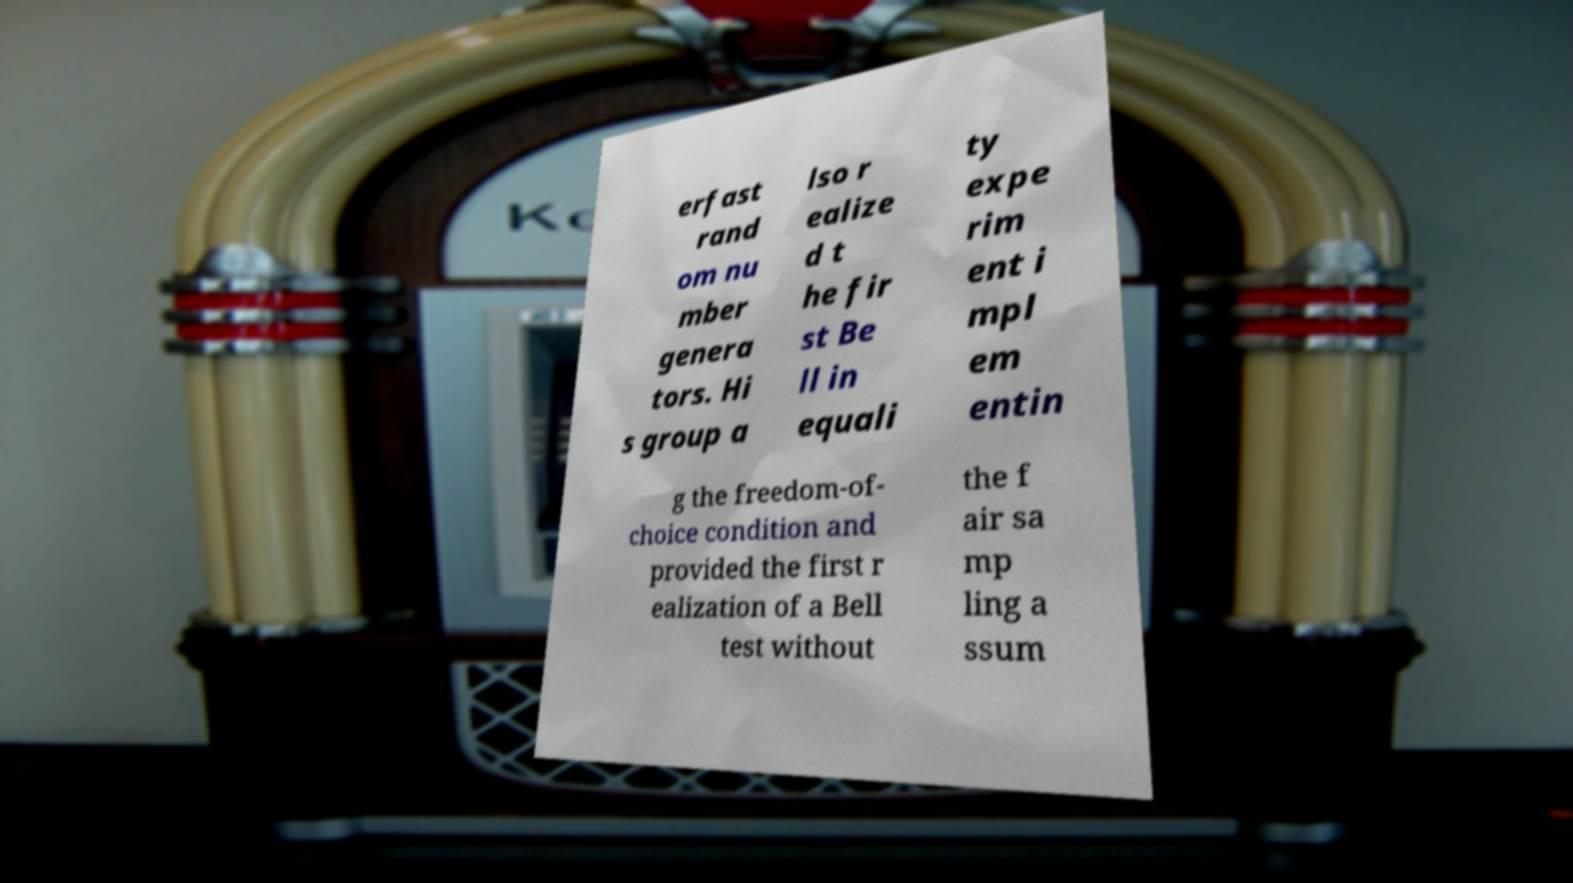Can you read and provide the text displayed in the image?This photo seems to have some interesting text. Can you extract and type it out for me? erfast rand om nu mber genera tors. Hi s group a lso r ealize d t he fir st Be ll in equali ty expe rim ent i mpl em entin g the freedom-of- choice condition and provided the first r ealization of a Bell test without the f air sa mp ling a ssum 